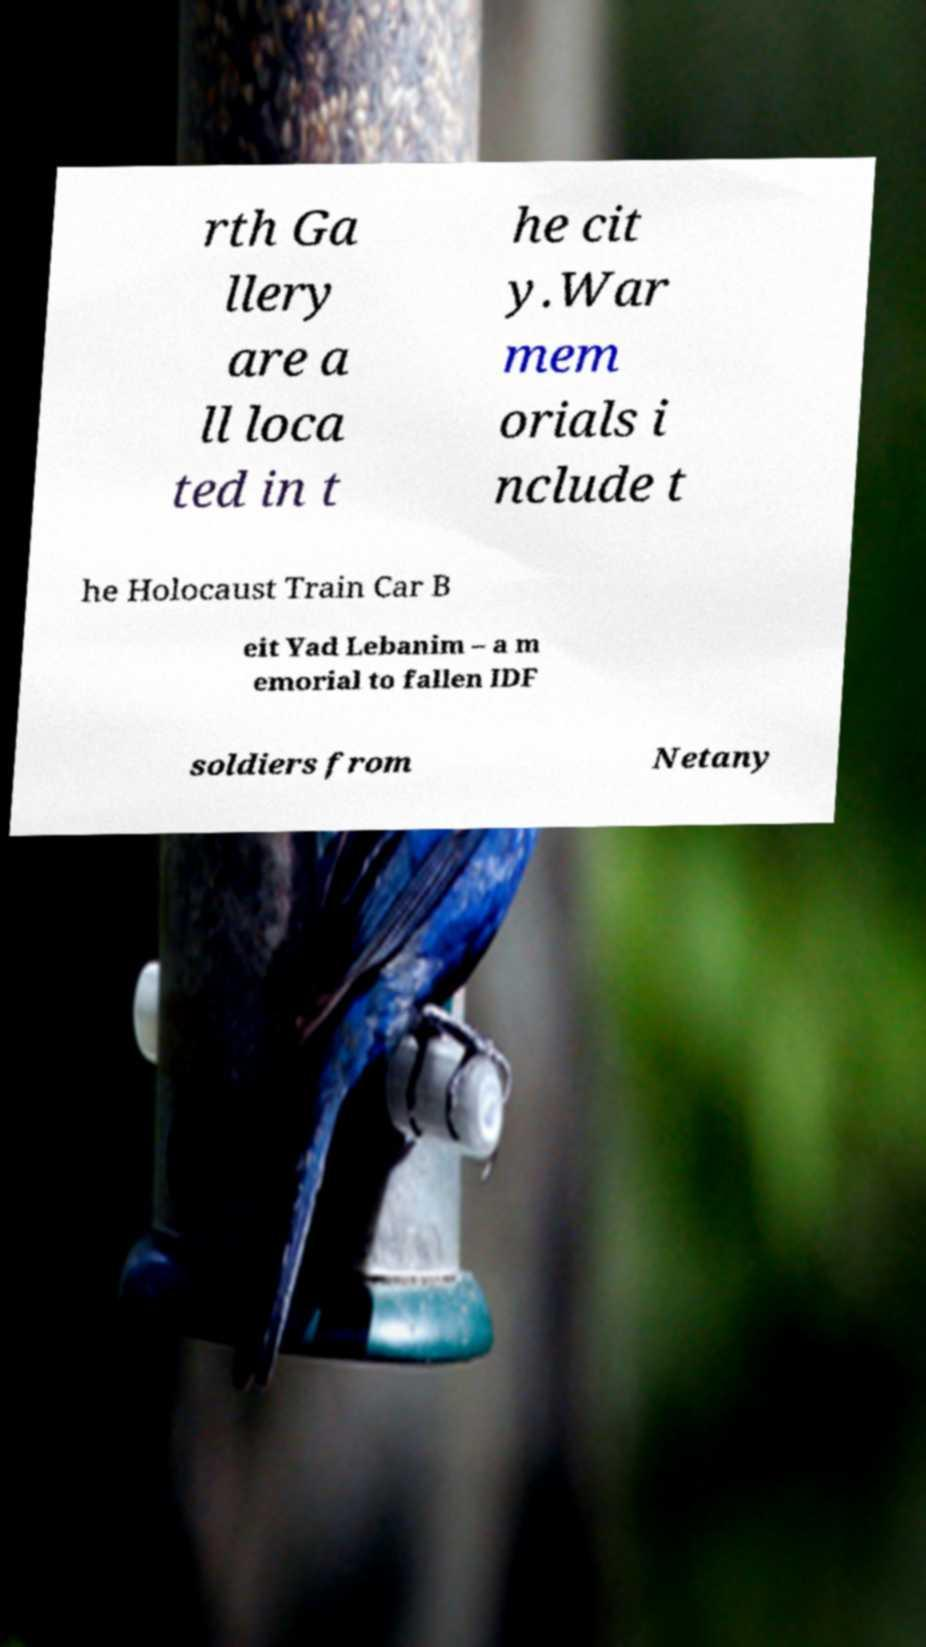There's text embedded in this image that I need extracted. Can you transcribe it verbatim? rth Ga llery are a ll loca ted in t he cit y.War mem orials i nclude t he Holocaust Train Car B eit Yad Lebanim – a m emorial to fallen IDF soldiers from Netany 